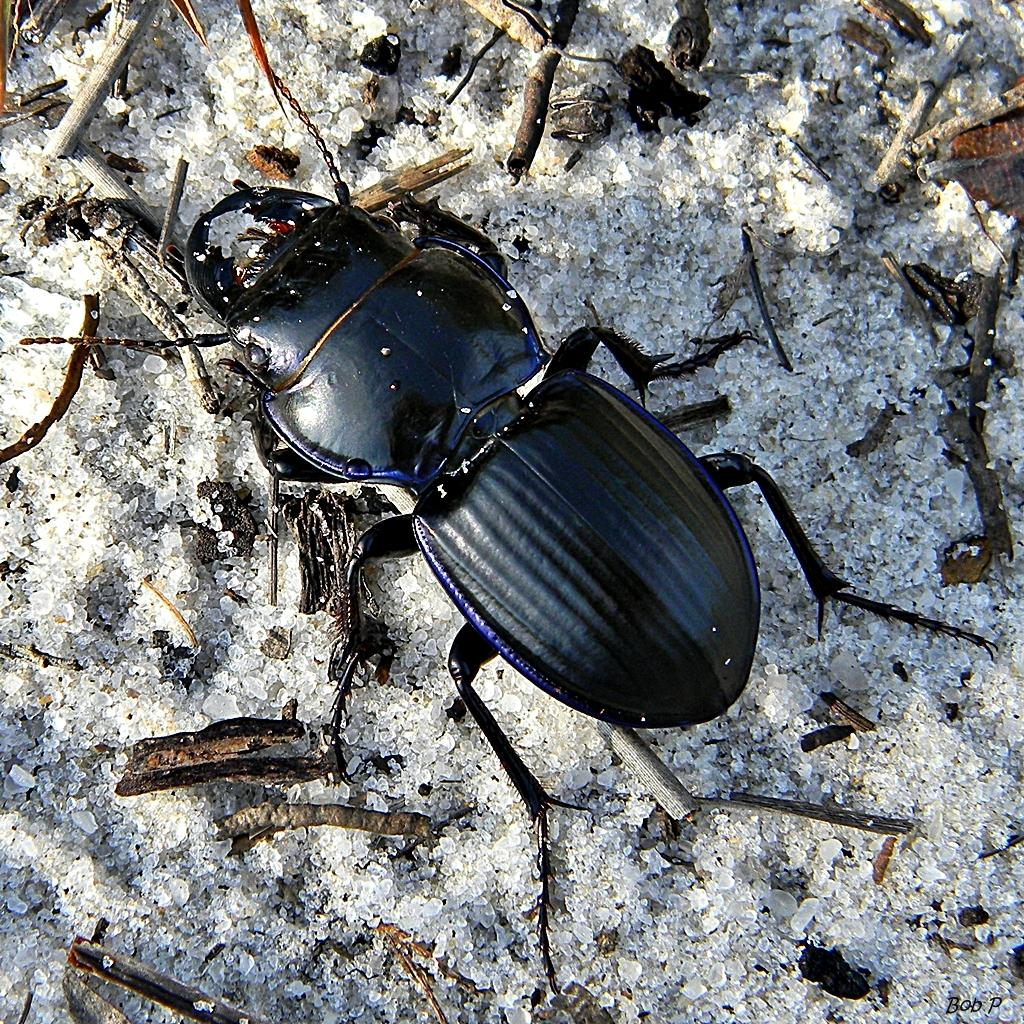What type of creature can be seen in the image? There is an insect in the image. What objects are made of wood in the image? There are wooden sticks in the image. How many cars are visible in the image? There are no cars present in the image; it only features an insect and wooden sticks. Are there any boats visible in the image? There are no boats present in the image; it only features an insect and wooden sticks. 